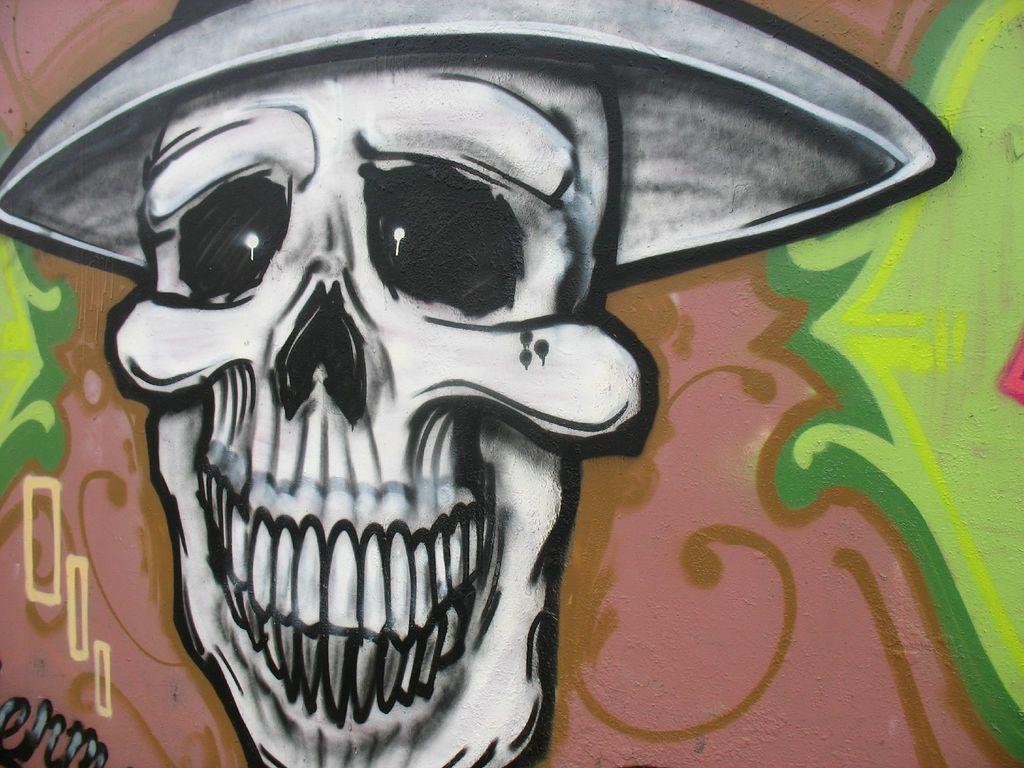In one or two sentences, can you explain what this image depicts? In this image there is a painting of a skull and some other designs on the wall. 